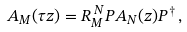Convert formula to latex. <formula><loc_0><loc_0><loc_500><loc_500>A _ { M } ( \tau z ) = R _ { M } ^ { \, N } P A _ { N } ( z ) P ^ { \dag } \, ,</formula> 